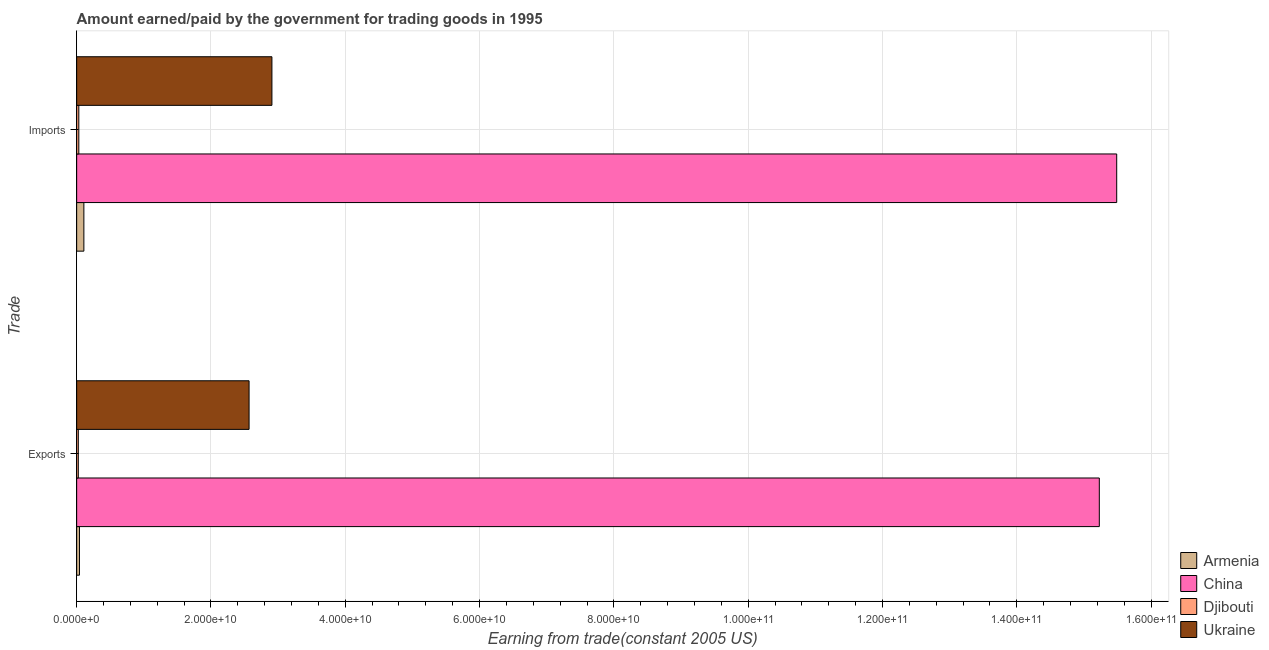How many groups of bars are there?
Ensure brevity in your answer.  2. How many bars are there on the 1st tick from the top?
Make the answer very short. 4. What is the label of the 1st group of bars from the top?
Your answer should be very brief. Imports. What is the amount earned from exports in Djibouti?
Offer a very short reply. 2.45e+08. Across all countries, what is the maximum amount earned from exports?
Give a very brief answer. 1.52e+11. Across all countries, what is the minimum amount paid for imports?
Give a very brief answer. 3.21e+08. In which country was the amount earned from exports maximum?
Offer a terse response. China. In which country was the amount earned from exports minimum?
Your answer should be compact. Djibouti. What is the total amount earned from exports in the graph?
Your answer should be very brief. 1.79e+11. What is the difference between the amount paid for imports in Ukraine and that in Djibouti?
Make the answer very short. 2.88e+1. What is the difference between the amount earned from exports in Djibouti and the amount paid for imports in Armenia?
Provide a short and direct response. -8.29e+08. What is the average amount earned from exports per country?
Your response must be concise. 4.47e+1. What is the difference between the amount earned from exports and amount paid for imports in Armenia?
Ensure brevity in your answer.  -6.57e+08. In how many countries, is the amount paid for imports greater than 8000000000 US$?
Your response must be concise. 2. What is the ratio of the amount paid for imports in China to that in Djibouti?
Offer a very short reply. 483.09. Is the amount paid for imports in Ukraine less than that in China?
Ensure brevity in your answer.  Yes. What does the 2nd bar from the top in Exports represents?
Your answer should be compact. Djibouti. How many bars are there?
Provide a succinct answer. 8. What is the difference between two consecutive major ticks on the X-axis?
Provide a succinct answer. 2.00e+1. Does the graph contain any zero values?
Your answer should be very brief. No. Does the graph contain grids?
Your answer should be very brief. Yes. Where does the legend appear in the graph?
Provide a succinct answer. Bottom right. How many legend labels are there?
Give a very brief answer. 4. How are the legend labels stacked?
Provide a succinct answer. Vertical. What is the title of the graph?
Your answer should be very brief. Amount earned/paid by the government for trading goods in 1995. Does "Barbados" appear as one of the legend labels in the graph?
Your answer should be very brief. No. What is the label or title of the X-axis?
Ensure brevity in your answer.  Earning from trade(constant 2005 US). What is the label or title of the Y-axis?
Your answer should be compact. Trade. What is the Earning from trade(constant 2005 US) of Armenia in Exports?
Ensure brevity in your answer.  4.17e+08. What is the Earning from trade(constant 2005 US) of China in Exports?
Give a very brief answer. 1.52e+11. What is the Earning from trade(constant 2005 US) of Djibouti in Exports?
Your answer should be compact. 2.45e+08. What is the Earning from trade(constant 2005 US) in Ukraine in Exports?
Provide a succinct answer. 2.57e+1. What is the Earning from trade(constant 2005 US) in Armenia in Imports?
Ensure brevity in your answer.  1.07e+09. What is the Earning from trade(constant 2005 US) in China in Imports?
Your answer should be very brief. 1.55e+11. What is the Earning from trade(constant 2005 US) of Djibouti in Imports?
Your answer should be compact. 3.21e+08. What is the Earning from trade(constant 2005 US) in Ukraine in Imports?
Offer a very short reply. 2.91e+1. Across all Trade, what is the maximum Earning from trade(constant 2005 US) of Armenia?
Give a very brief answer. 1.07e+09. Across all Trade, what is the maximum Earning from trade(constant 2005 US) of China?
Give a very brief answer. 1.55e+11. Across all Trade, what is the maximum Earning from trade(constant 2005 US) of Djibouti?
Ensure brevity in your answer.  3.21e+08. Across all Trade, what is the maximum Earning from trade(constant 2005 US) of Ukraine?
Give a very brief answer. 2.91e+1. Across all Trade, what is the minimum Earning from trade(constant 2005 US) in Armenia?
Ensure brevity in your answer.  4.17e+08. Across all Trade, what is the minimum Earning from trade(constant 2005 US) in China?
Your answer should be very brief. 1.52e+11. Across all Trade, what is the minimum Earning from trade(constant 2005 US) in Djibouti?
Your answer should be very brief. 2.45e+08. Across all Trade, what is the minimum Earning from trade(constant 2005 US) in Ukraine?
Provide a succinct answer. 2.57e+1. What is the total Earning from trade(constant 2005 US) in Armenia in the graph?
Offer a terse response. 1.49e+09. What is the total Earning from trade(constant 2005 US) in China in the graph?
Give a very brief answer. 3.07e+11. What is the total Earning from trade(constant 2005 US) of Djibouti in the graph?
Provide a succinct answer. 5.66e+08. What is the total Earning from trade(constant 2005 US) in Ukraine in the graph?
Give a very brief answer. 5.48e+1. What is the difference between the Earning from trade(constant 2005 US) in Armenia in Exports and that in Imports?
Make the answer very short. -6.57e+08. What is the difference between the Earning from trade(constant 2005 US) of China in Exports and that in Imports?
Your answer should be very brief. -2.59e+09. What is the difference between the Earning from trade(constant 2005 US) in Djibouti in Exports and that in Imports?
Offer a very short reply. -7.56e+07. What is the difference between the Earning from trade(constant 2005 US) in Ukraine in Exports and that in Imports?
Provide a succinct answer. -3.40e+09. What is the difference between the Earning from trade(constant 2005 US) in Armenia in Exports and the Earning from trade(constant 2005 US) in China in Imports?
Your answer should be compact. -1.54e+11. What is the difference between the Earning from trade(constant 2005 US) in Armenia in Exports and the Earning from trade(constant 2005 US) in Djibouti in Imports?
Make the answer very short. 9.69e+07. What is the difference between the Earning from trade(constant 2005 US) of Armenia in Exports and the Earning from trade(constant 2005 US) of Ukraine in Imports?
Provide a succinct answer. -2.87e+1. What is the difference between the Earning from trade(constant 2005 US) in China in Exports and the Earning from trade(constant 2005 US) in Djibouti in Imports?
Give a very brief answer. 1.52e+11. What is the difference between the Earning from trade(constant 2005 US) of China in Exports and the Earning from trade(constant 2005 US) of Ukraine in Imports?
Your answer should be very brief. 1.23e+11. What is the difference between the Earning from trade(constant 2005 US) of Djibouti in Exports and the Earning from trade(constant 2005 US) of Ukraine in Imports?
Offer a very short reply. -2.88e+1. What is the average Earning from trade(constant 2005 US) of Armenia per Trade?
Provide a succinct answer. 7.46e+08. What is the average Earning from trade(constant 2005 US) in China per Trade?
Give a very brief answer. 1.54e+11. What is the average Earning from trade(constant 2005 US) in Djibouti per Trade?
Your response must be concise. 2.83e+08. What is the average Earning from trade(constant 2005 US) of Ukraine per Trade?
Give a very brief answer. 2.74e+1. What is the difference between the Earning from trade(constant 2005 US) in Armenia and Earning from trade(constant 2005 US) in China in Exports?
Your answer should be compact. -1.52e+11. What is the difference between the Earning from trade(constant 2005 US) in Armenia and Earning from trade(constant 2005 US) in Djibouti in Exports?
Your answer should be very brief. 1.72e+08. What is the difference between the Earning from trade(constant 2005 US) of Armenia and Earning from trade(constant 2005 US) of Ukraine in Exports?
Provide a short and direct response. -2.53e+1. What is the difference between the Earning from trade(constant 2005 US) of China and Earning from trade(constant 2005 US) of Djibouti in Exports?
Give a very brief answer. 1.52e+11. What is the difference between the Earning from trade(constant 2005 US) in China and Earning from trade(constant 2005 US) in Ukraine in Exports?
Provide a short and direct response. 1.27e+11. What is the difference between the Earning from trade(constant 2005 US) of Djibouti and Earning from trade(constant 2005 US) of Ukraine in Exports?
Provide a succinct answer. -2.54e+1. What is the difference between the Earning from trade(constant 2005 US) of Armenia and Earning from trade(constant 2005 US) of China in Imports?
Provide a succinct answer. -1.54e+11. What is the difference between the Earning from trade(constant 2005 US) in Armenia and Earning from trade(constant 2005 US) in Djibouti in Imports?
Your response must be concise. 7.54e+08. What is the difference between the Earning from trade(constant 2005 US) in Armenia and Earning from trade(constant 2005 US) in Ukraine in Imports?
Provide a succinct answer. -2.80e+1. What is the difference between the Earning from trade(constant 2005 US) of China and Earning from trade(constant 2005 US) of Djibouti in Imports?
Provide a short and direct response. 1.55e+11. What is the difference between the Earning from trade(constant 2005 US) of China and Earning from trade(constant 2005 US) of Ukraine in Imports?
Provide a succinct answer. 1.26e+11. What is the difference between the Earning from trade(constant 2005 US) in Djibouti and Earning from trade(constant 2005 US) in Ukraine in Imports?
Your answer should be very brief. -2.88e+1. What is the ratio of the Earning from trade(constant 2005 US) of Armenia in Exports to that in Imports?
Give a very brief answer. 0.39. What is the ratio of the Earning from trade(constant 2005 US) in China in Exports to that in Imports?
Give a very brief answer. 0.98. What is the ratio of the Earning from trade(constant 2005 US) in Djibouti in Exports to that in Imports?
Make the answer very short. 0.76. What is the ratio of the Earning from trade(constant 2005 US) in Ukraine in Exports to that in Imports?
Give a very brief answer. 0.88. What is the difference between the highest and the second highest Earning from trade(constant 2005 US) in Armenia?
Keep it short and to the point. 6.57e+08. What is the difference between the highest and the second highest Earning from trade(constant 2005 US) in China?
Offer a terse response. 2.59e+09. What is the difference between the highest and the second highest Earning from trade(constant 2005 US) of Djibouti?
Ensure brevity in your answer.  7.56e+07. What is the difference between the highest and the second highest Earning from trade(constant 2005 US) of Ukraine?
Provide a succinct answer. 3.40e+09. What is the difference between the highest and the lowest Earning from trade(constant 2005 US) of Armenia?
Give a very brief answer. 6.57e+08. What is the difference between the highest and the lowest Earning from trade(constant 2005 US) in China?
Give a very brief answer. 2.59e+09. What is the difference between the highest and the lowest Earning from trade(constant 2005 US) in Djibouti?
Your answer should be very brief. 7.56e+07. What is the difference between the highest and the lowest Earning from trade(constant 2005 US) of Ukraine?
Your response must be concise. 3.40e+09. 